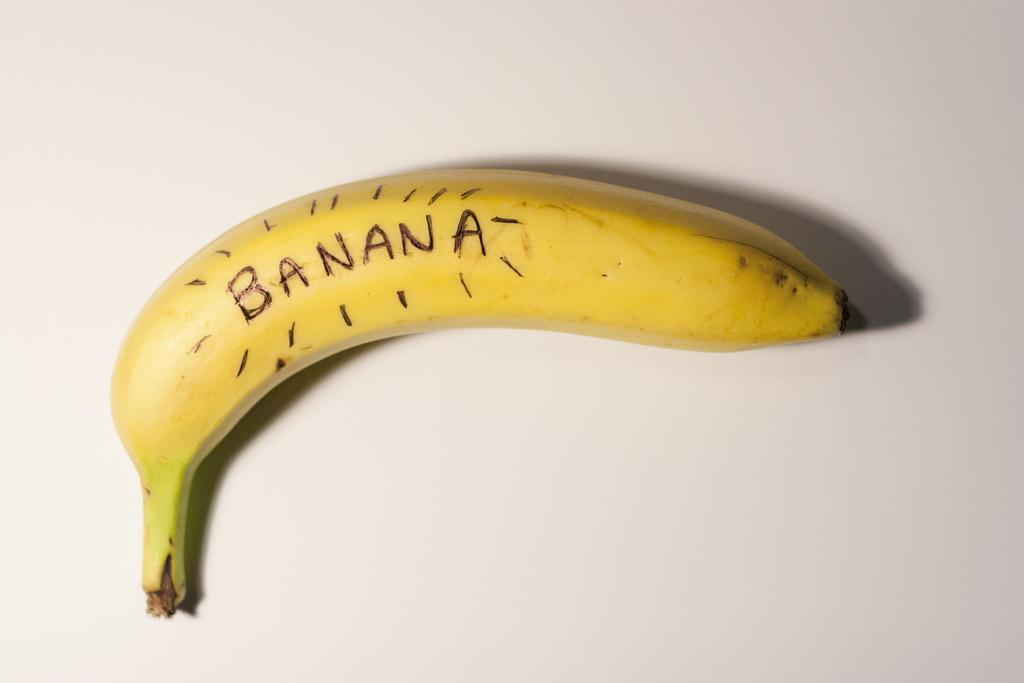<image>
Provide a brief description of the given image. A yellow banana sitting on a white background with the word banana written on it in black. 